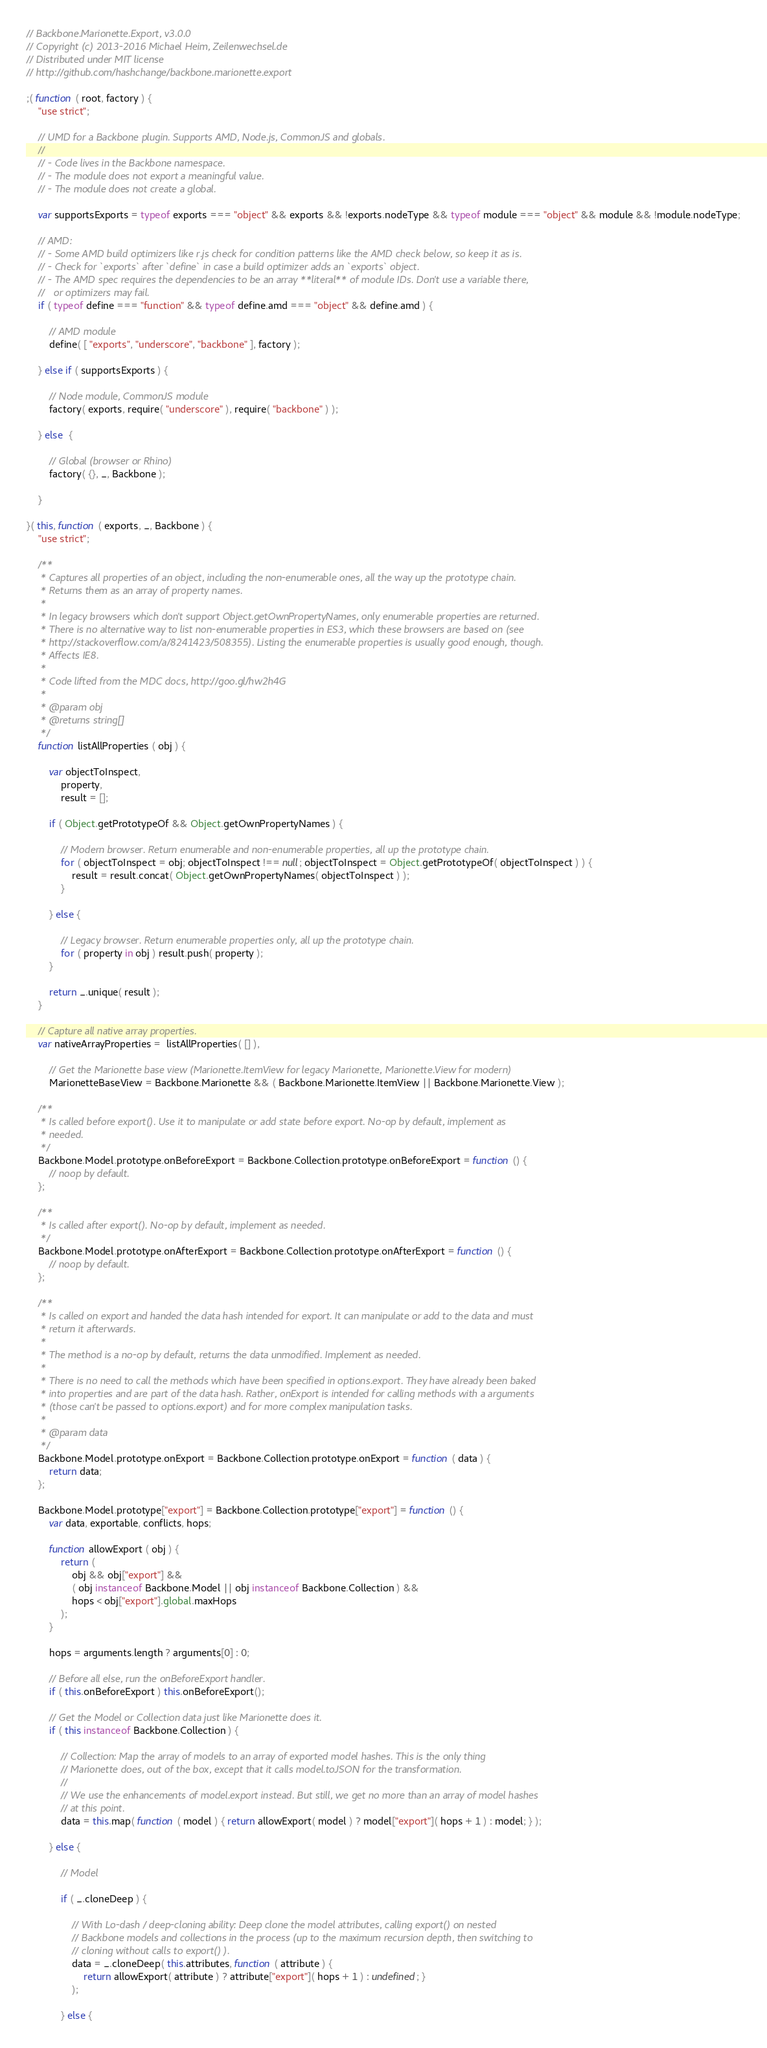Convert code to text. <code><loc_0><loc_0><loc_500><loc_500><_JavaScript_>// Backbone.Marionette.Export, v3.0.0
// Copyright (c) 2013-2016 Michael Heim, Zeilenwechsel.de
// Distributed under MIT license
// http://github.com/hashchange/backbone.marionette.export

;( function ( root, factory ) {
    "use strict";

    // UMD for a Backbone plugin. Supports AMD, Node.js, CommonJS and globals.
    //
    // - Code lives in the Backbone namespace.
    // - The module does not export a meaningful value.
    // - The module does not create a global.

    var supportsExports = typeof exports === "object" && exports && !exports.nodeType && typeof module === "object" && module && !module.nodeType;

    // AMD:
    // - Some AMD build optimizers like r.js check for condition patterns like the AMD check below, so keep it as is.
    // - Check for `exports` after `define` in case a build optimizer adds an `exports` object.
    // - The AMD spec requires the dependencies to be an array **literal** of module IDs. Don't use a variable there,
    //   or optimizers may fail.
    if ( typeof define === "function" && typeof define.amd === "object" && define.amd ) {

        // AMD module
        define( [ "exports", "underscore", "backbone" ], factory );

    } else if ( supportsExports ) {

        // Node module, CommonJS module
        factory( exports, require( "underscore" ), require( "backbone" ) );

    } else  {

        // Global (browser or Rhino)
        factory( {}, _, Backbone );

    }

}( this, function ( exports, _, Backbone ) {
    "use strict";

    /**
     * Captures all properties of an object, including the non-enumerable ones, all the way up the prototype chain.
     * Returns them as an array of property names.
     *
     * In legacy browsers which don't support Object.getOwnPropertyNames, only enumerable properties are returned.
     * There is no alternative way to list non-enumerable properties in ES3, which these browsers are based on (see
     * http://stackoverflow.com/a/8241423/508355). Listing the enumerable properties is usually good enough, though.
     * Affects IE8.
     *
     * Code lifted from the MDC docs, http://goo.gl/hw2h4G
     *
     * @param obj
     * @returns string[]
     */
    function listAllProperties ( obj ) {

        var objectToInspect,
            property,
            result = [];

        if ( Object.getPrototypeOf && Object.getOwnPropertyNames ) {

            // Modern browser. Return enumerable and non-enumerable properties, all up the prototype chain.
            for ( objectToInspect = obj; objectToInspect !== null; objectToInspect = Object.getPrototypeOf( objectToInspect ) ) {
                result = result.concat( Object.getOwnPropertyNames( objectToInspect ) );
            }

        } else {

            // Legacy browser. Return enumerable properties only, all up the prototype chain.
            for ( property in obj ) result.push( property );
        }

        return _.unique( result );
    }

    // Capture all native array properties.
    var nativeArrayProperties =  listAllProperties( [] ),

        // Get the Marionette base view (Marionette.ItemView for legacy Marionette, Marionette.View for modern)
        MarionetteBaseView = Backbone.Marionette && ( Backbone.Marionette.ItemView || Backbone.Marionette.View );

    /**
     * Is called before export(). Use it to manipulate or add state before export. No-op by default, implement as
     * needed.
     */
    Backbone.Model.prototype.onBeforeExport = Backbone.Collection.prototype.onBeforeExport = function () {
        // noop by default.
    };

    /**
     * Is called after export(). No-op by default, implement as needed.
     */
    Backbone.Model.prototype.onAfterExport = Backbone.Collection.prototype.onAfterExport = function () {
        // noop by default.
    };

    /**
     * Is called on export and handed the data hash intended for export. It can manipulate or add to the data and must
     * return it afterwards.
     *
     * The method is a no-op by default, returns the data unmodified. Implement as needed.
     *
     * There is no need to call the methods which have been specified in options.export. They have already been baked
     * into properties and are part of the data hash. Rather, onExport is intended for calling methods with a arguments
     * (those can't be passed to options.export) and for more complex manipulation tasks.
     *
     * @param data
     */
    Backbone.Model.prototype.onExport = Backbone.Collection.prototype.onExport = function ( data ) {
        return data;
    };

    Backbone.Model.prototype["export"] = Backbone.Collection.prototype["export"] = function () {
        var data, exportable, conflicts, hops;

        function allowExport ( obj ) {
            return (
                obj && obj["export"] &&
                ( obj instanceof Backbone.Model || obj instanceof Backbone.Collection ) &&
                hops < obj["export"].global.maxHops
            );
        }

        hops = arguments.length ? arguments[0] : 0;

        // Before all else, run the onBeforeExport handler.
        if ( this.onBeforeExport ) this.onBeforeExport();

        // Get the Model or Collection data just like Marionette does it.
        if ( this instanceof Backbone.Collection ) {

            // Collection: Map the array of models to an array of exported model hashes. This is the only thing
            // Marionette does, out of the box, except that it calls model.toJSON for the transformation.
            //
            // We use the enhancements of model.export instead. But still, we get no more than an array of model hashes
            // at this point.
            data = this.map( function ( model ) { return allowExport( model ) ? model["export"]( hops + 1 ) : model; } );

        } else {

            // Model

            if ( _.cloneDeep ) {

                // With Lo-dash / deep-cloning ability: Deep clone the model attributes, calling export() on nested
                // Backbone models and collections in the process (up to the maximum recursion depth, then switching to
                // cloning without calls to export() ).
                data = _.cloneDeep( this.attributes, function ( attribute ) {
                    return allowExport( attribute ) ? attribute["export"]( hops + 1 ) : undefined; }
                );

            } else {
</code> 